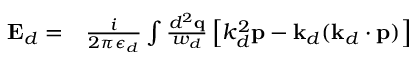Convert formula to latex. <formula><loc_0><loc_0><loc_500><loc_500>\begin{array} { r l } { E _ { d } = } & \frac { i } { 2 \pi \epsilon _ { d } } \int \frac { d ^ { 2 } q } { w _ { d } } \left [ k _ { d } ^ { 2 } p - k _ { d } ( k _ { d } \cdot p ) \right ] } \end{array}</formula> 